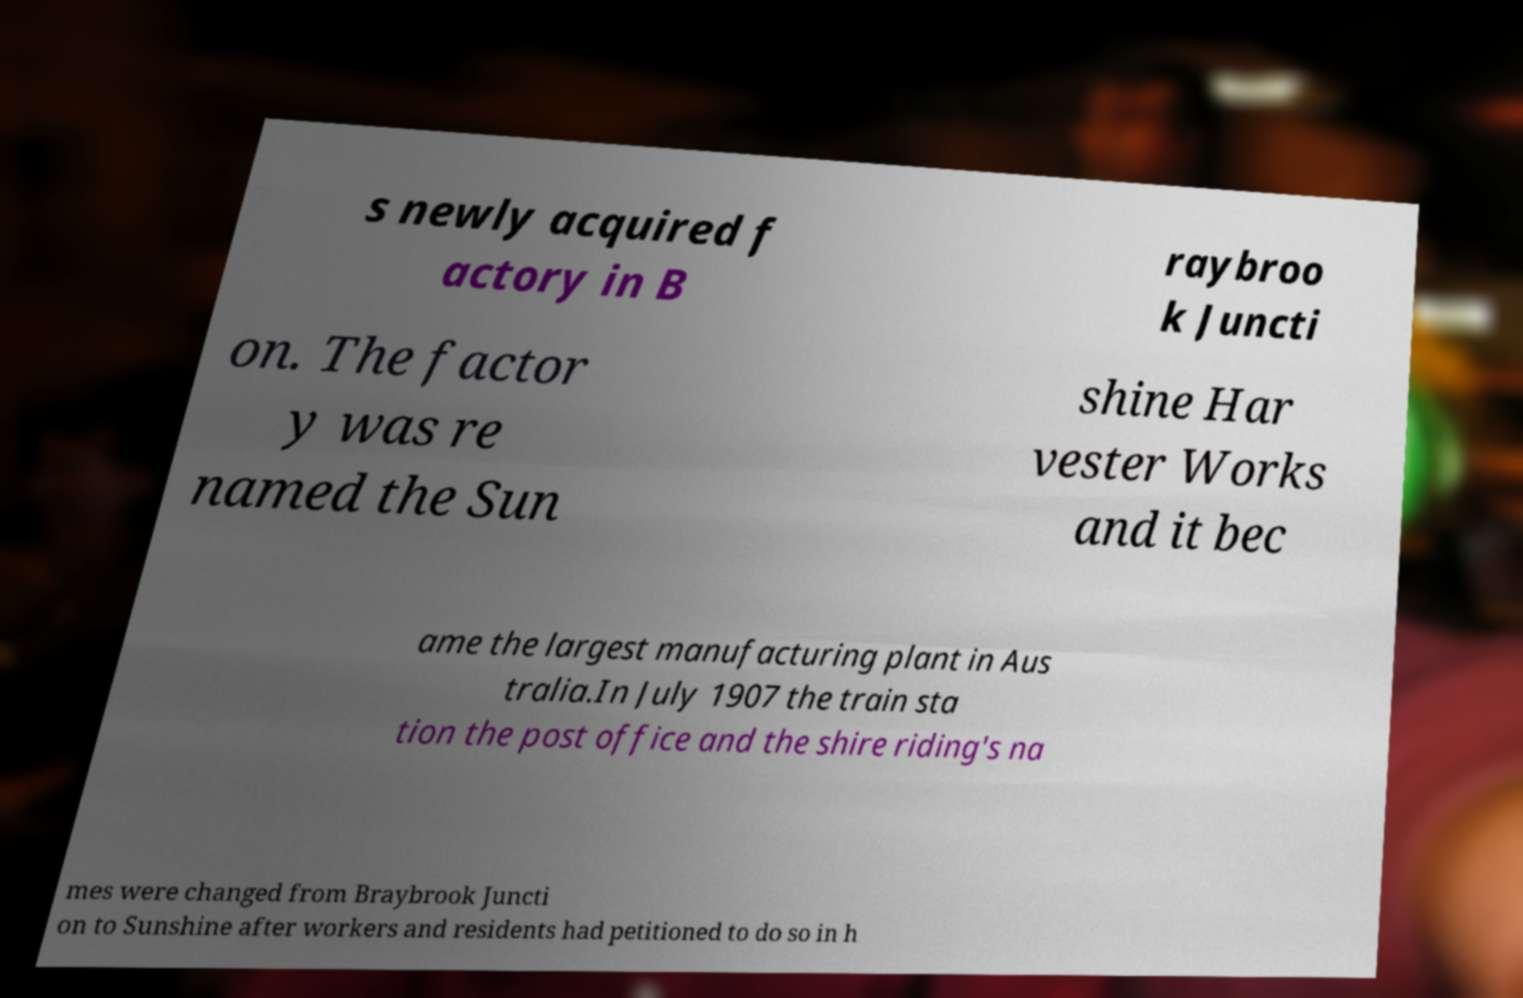Could you extract and type out the text from this image? s newly acquired f actory in B raybroo k Juncti on. The factor y was re named the Sun shine Har vester Works and it bec ame the largest manufacturing plant in Aus tralia.In July 1907 the train sta tion the post office and the shire riding's na mes were changed from Braybrook Juncti on to Sunshine after workers and residents had petitioned to do so in h 